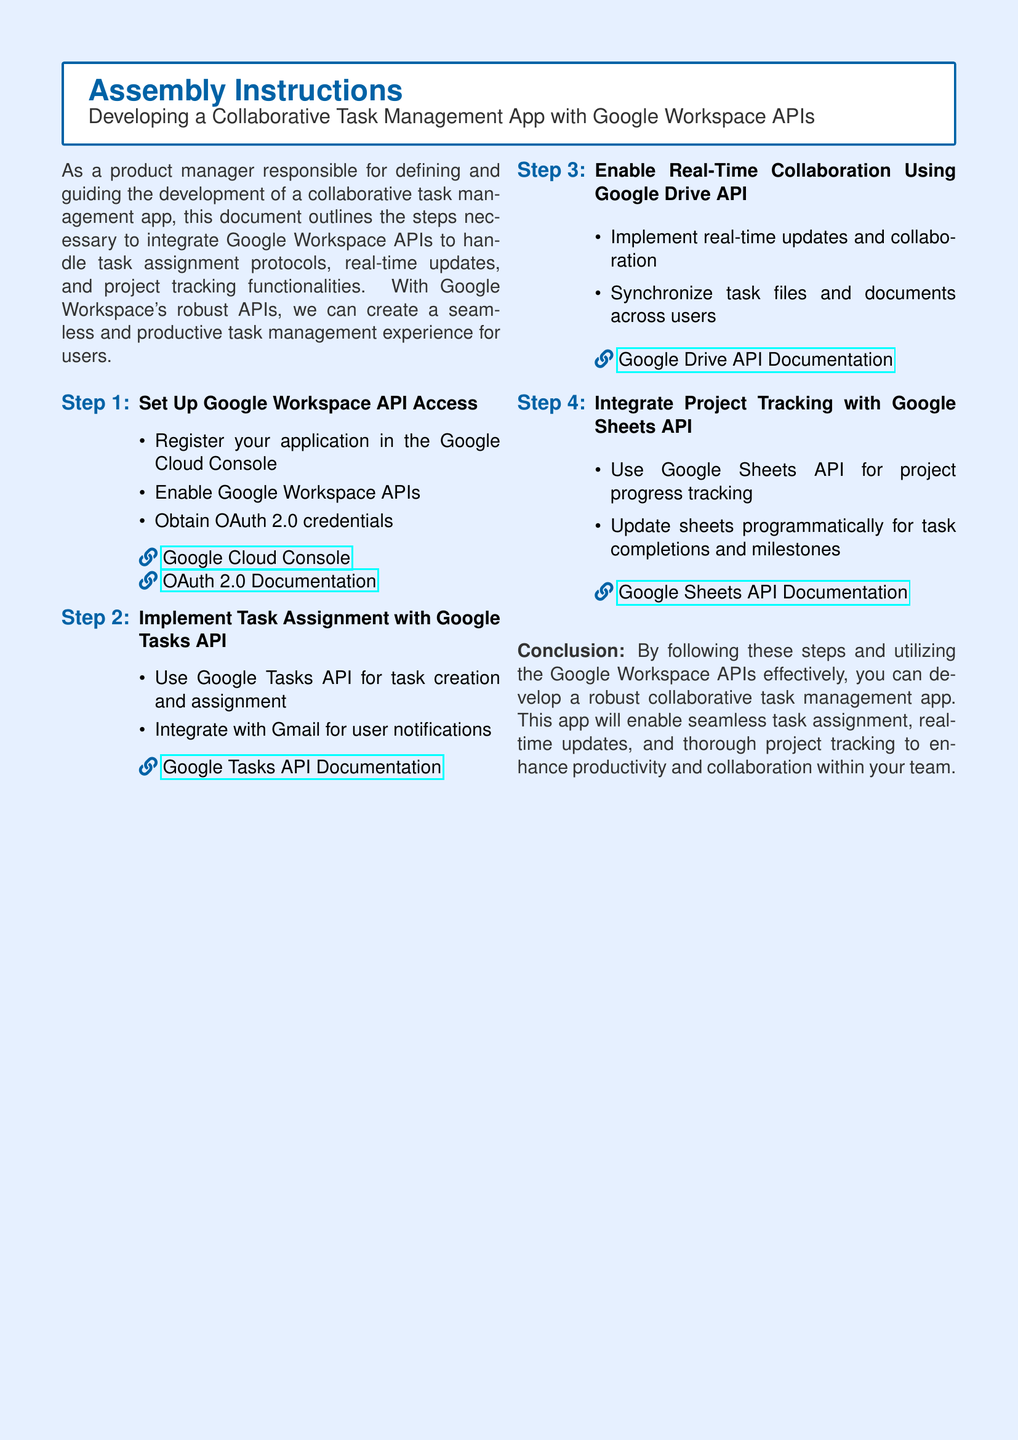What is the title of the document? The title of the document is prominently displayed at the top.
Answer: Assembly Instructions How many steps are outlined in the document? The number of steps can be counted in the enumerated list.
Answer: Four Which API is used for task creation and assignment? The specific API for task assignment is mentioned in the context of task management.
Answer: Google Tasks API What is the primary purpose of the Google Sheets API in this app? The document describes the use of the Google Sheets API in a specific context related to project management.
Answer: Project progress tracking Which link leads to the OAuth 2.0 Documentation? The document includes hyperlinks to resources, including one for OAuth 2.0.
Answer: OAuth 2.0 Documentation What functionality does the Google Drive API provide? The document states the specific role of the Google Drive API in context to the application.
Answer: Real-time updates and collaboration What type of app is being developed? The document specifies the nature of the application being created.
Answer: Collaborative task management app What is the conclusion stated in the document? The conclusion summarizes the overall objectives and outcomes of following the outlined steps.
Answer: A robust collaborative task management app 